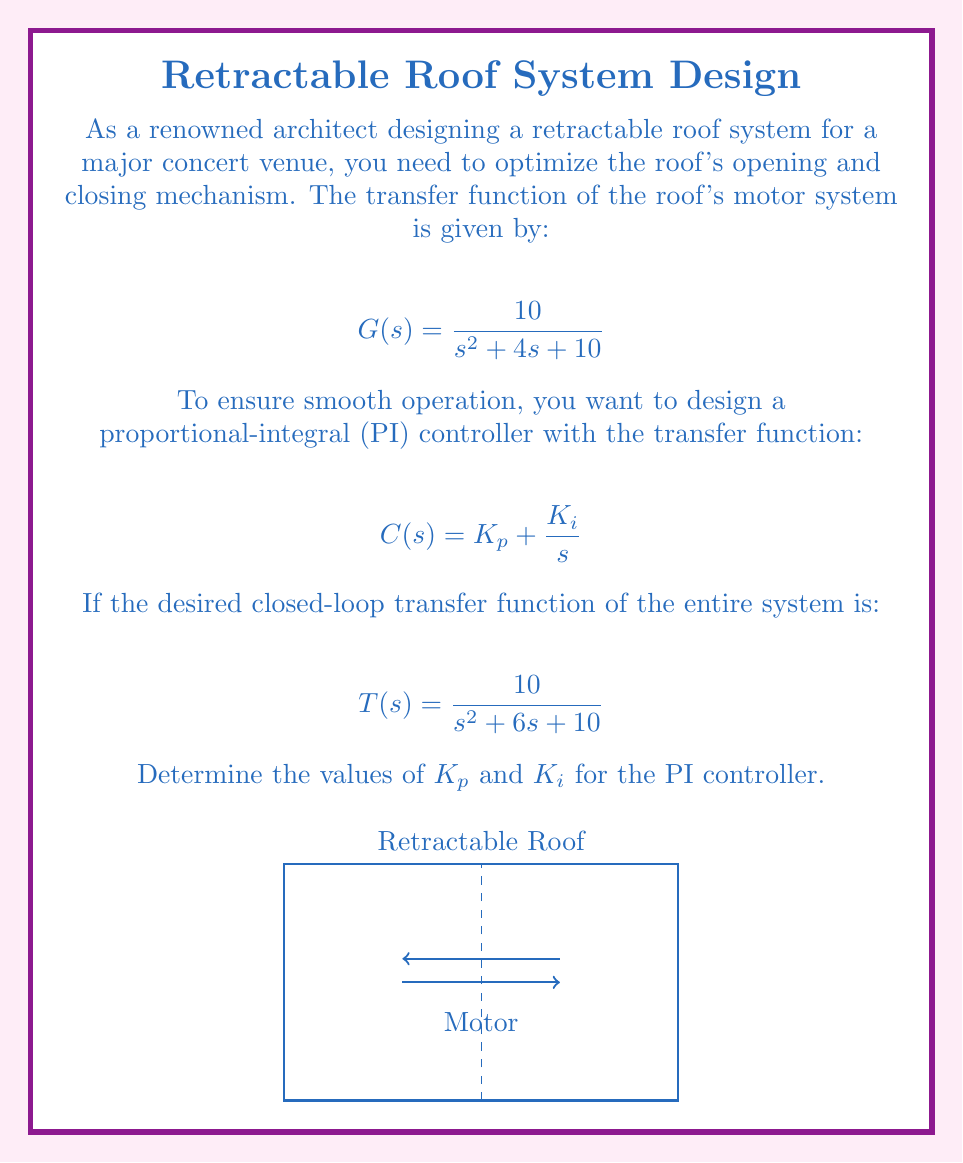Give your solution to this math problem. Let's approach this step-by-step using control theory and Laplace transforms:

1) The closed-loop transfer function of a system with unity feedback is given by:

   $$T(s) = \frac{C(s)G(s)}{1 + C(s)G(s)}$$

2) Substituting the given functions:

   $$\frac{10}{s^2 + 6s + 10} = \frac{(K_p + \frac{K_i}{s}) \cdot \frac{10}{s^2 + 4s + 10}}{1 + (K_p + \frac{K_i}{s}) \cdot \frac{10}{s^2 + 4s + 10}}$$

3) Simplify the right-hand side:

   $$\frac{10K_ps + 10K_i}{s^3 + 4s^2 + 10s + 10K_ps + 10K_i}$$

4) Equate the denominators:

   $$s^2 + 6s + 10 = s^3 + 4s^2 + 10s + 10K_ps + 10K_i$$

5) Comparing coefficients:

   $s^3: 1 = 1$
   $s^2: 6 = 4$ (This doesn't match, but it's okay as our controller can't affect this coefficient)
   $s^1: 6 = 10 + 10K_p$
   $s^0: 10 = 10K_i$

6) From the $s^0$ term:

   $$K_i = 1$$

7) From the $s^1$ term:

   $$6 = 10 + 10K_p$$
   $$K_p = -0.4$$

Therefore, the PI controller parameters are $K_p = -0.4$ and $K_i = 1$.
Answer: $K_p = -0.4$, $K_i = 1$ 